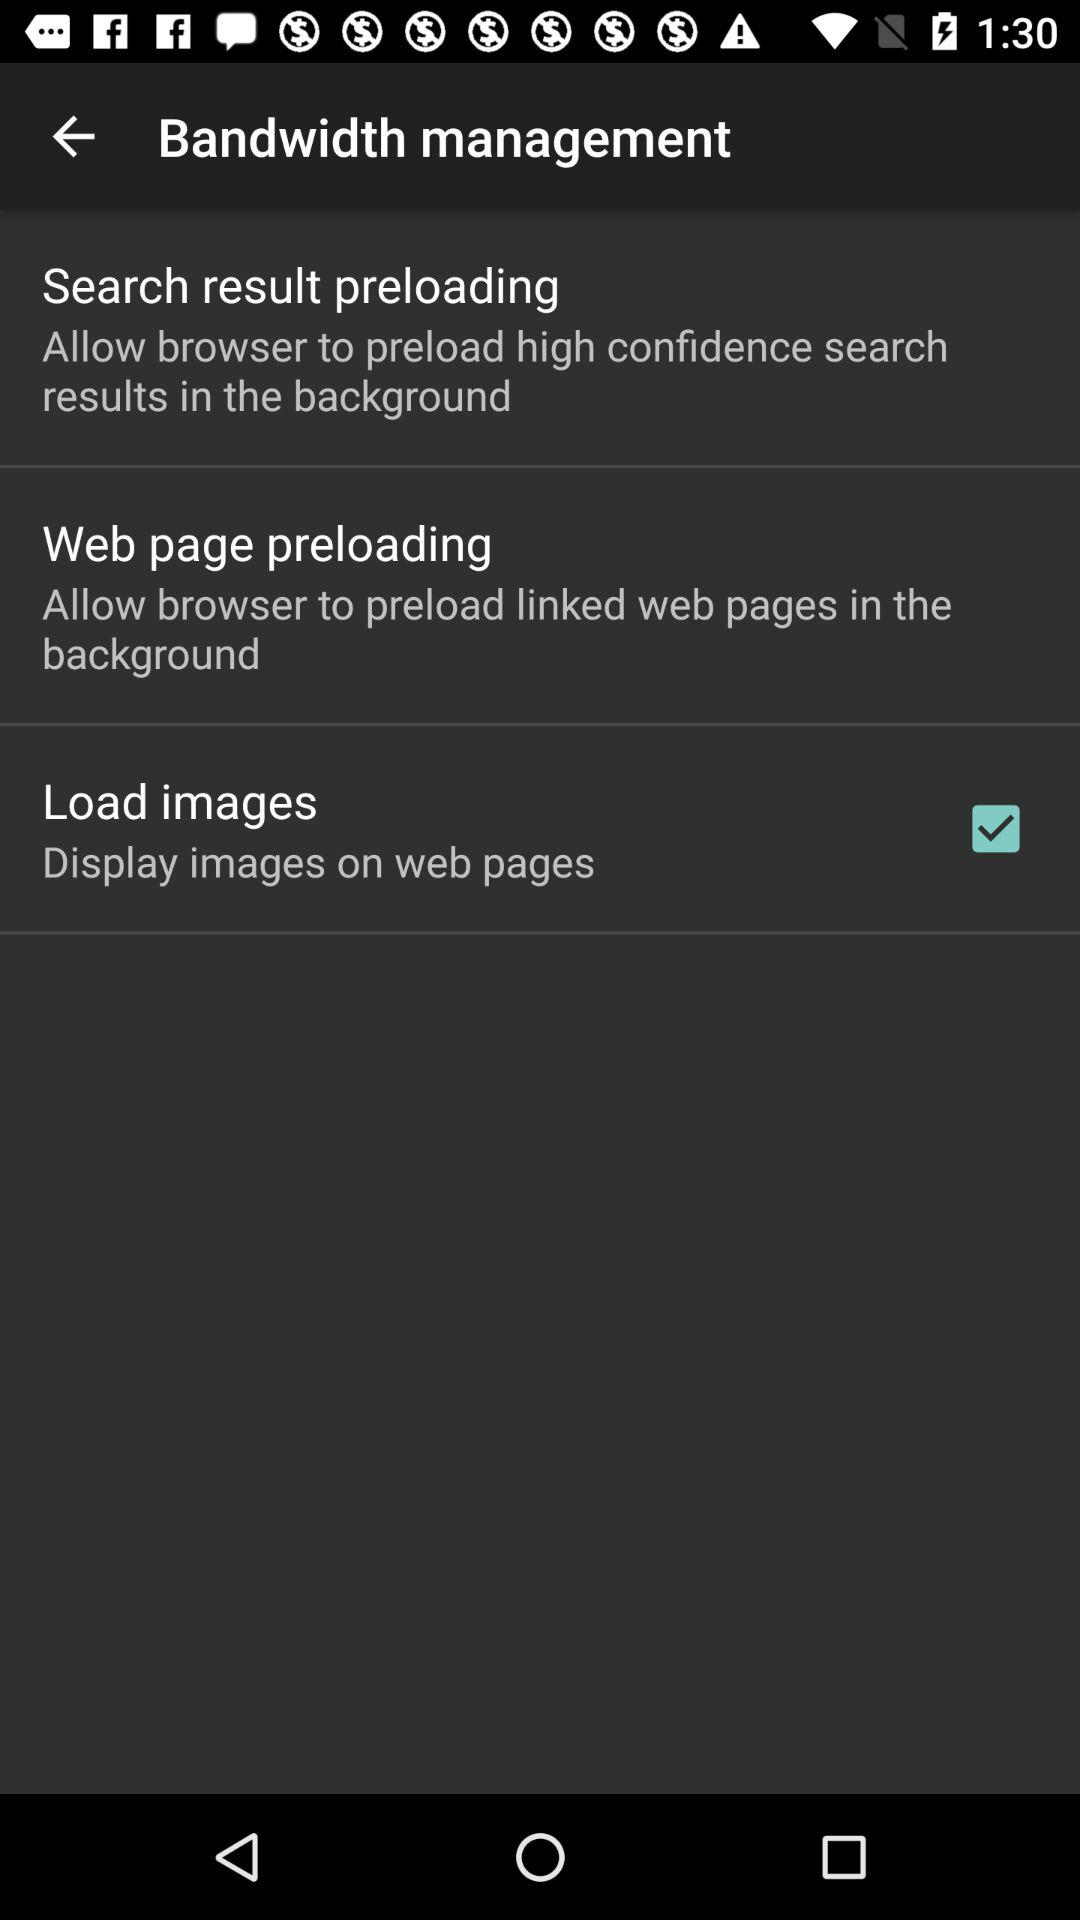What is the status of the "Load images"? The status is "on". 